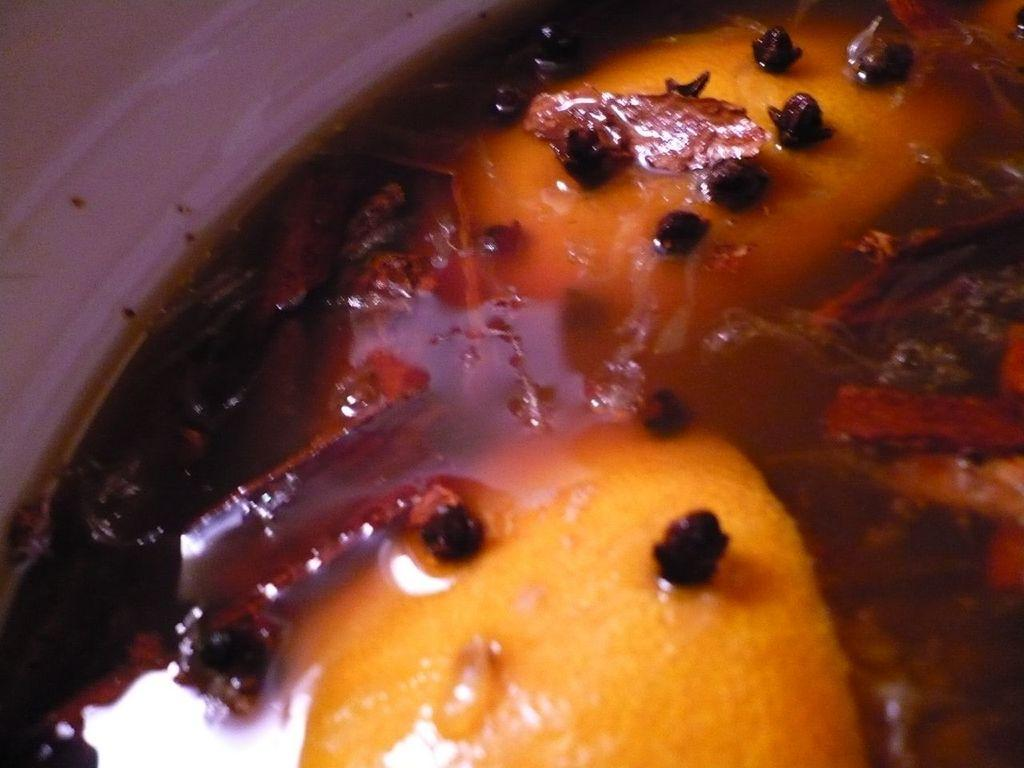Can you describe the main subject or objects in the image? Unfortunately, there are no specific details provided about the image, so it is impossible to describe the main subject or objects. How much payment is required to lead the top performers in the image? There is no information about payment, top performers, or any other specific details in the image, so it is impossible to answer this question. 